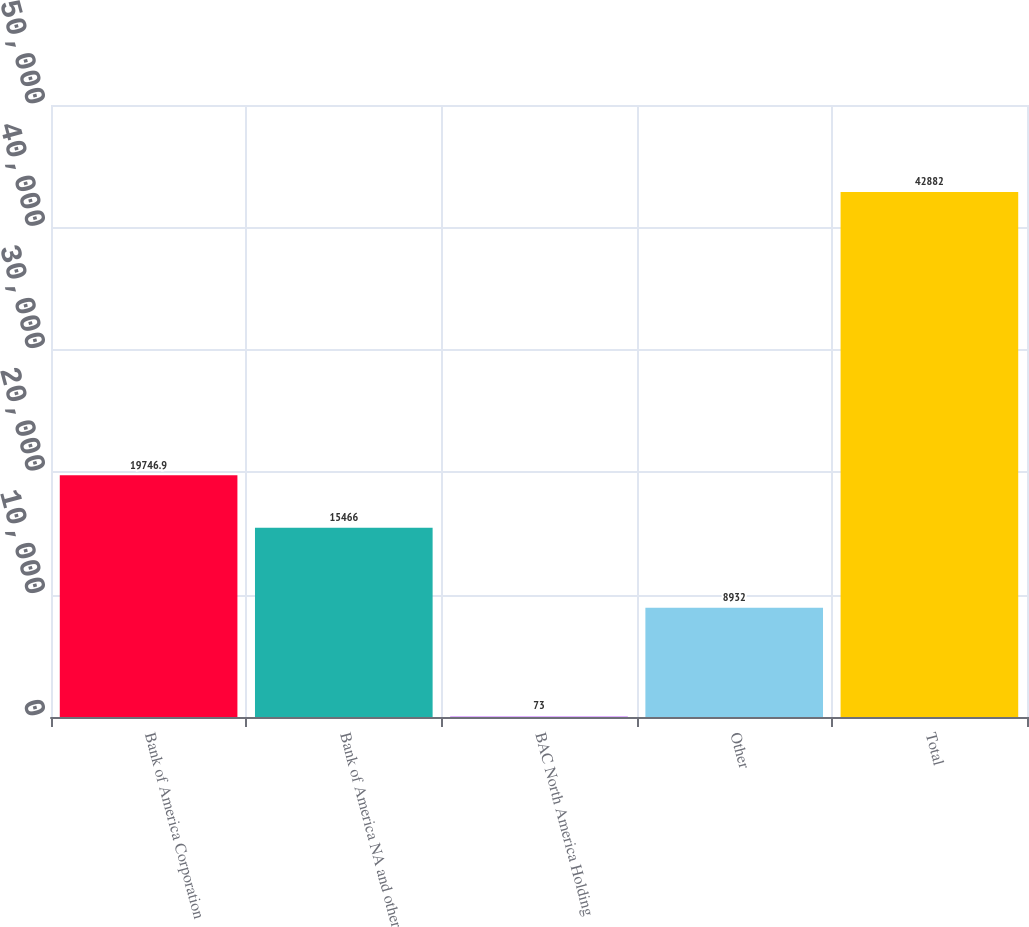Convert chart. <chart><loc_0><loc_0><loc_500><loc_500><bar_chart><fcel>Bank of America Corporation<fcel>Bank of America NA and other<fcel>BAC North America Holding<fcel>Other<fcel>Total<nl><fcel>19746.9<fcel>15466<fcel>73<fcel>8932<fcel>42882<nl></chart> 